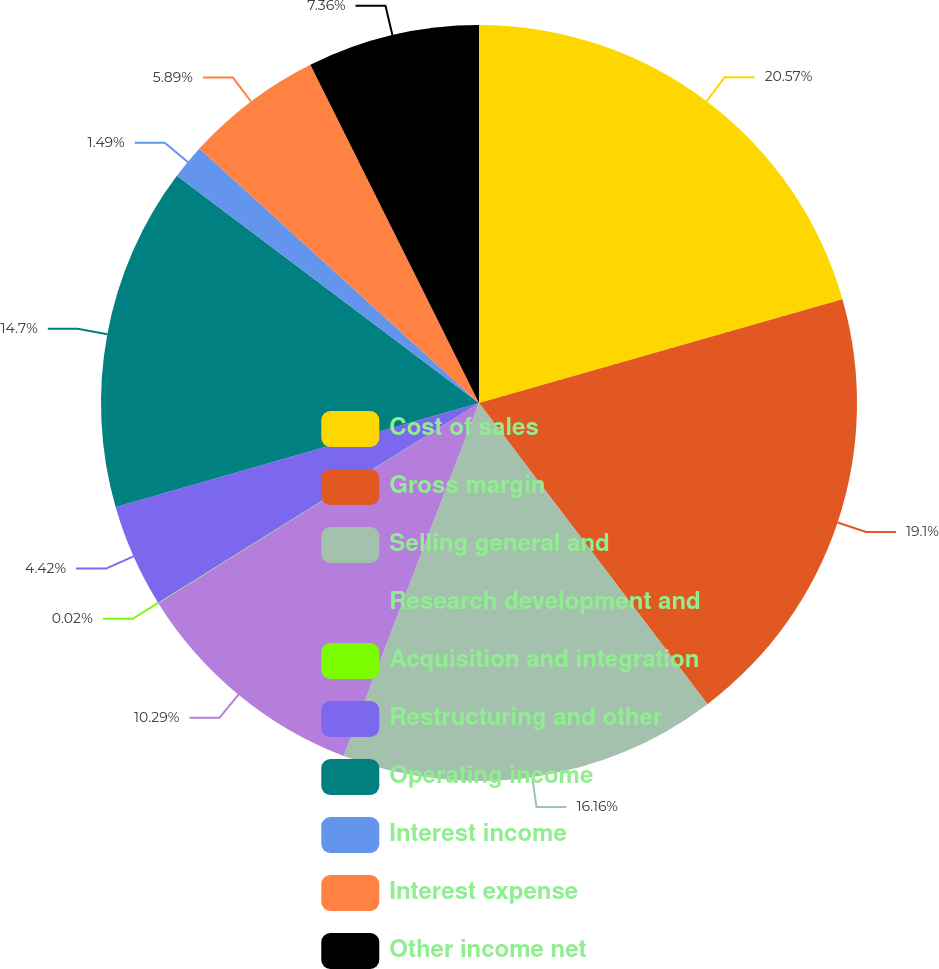Convert chart. <chart><loc_0><loc_0><loc_500><loc_500><pie_chart><fcel>Cost of sales<fcel>Gross margin<fcel>Selling general and<fcel>Research development and<fcel>Acquisition and integration<fcel>Restructuring and other<fcel>Operating income<fcel>Interest income<fcel>Interest expense<fcel>Other income net<nl><fcel>20.57%<fcel>19.1%<fcel>16.16%<fcel>10.29%<fcel>0.02%<fcel>4.42%<fcel>14.7%<fcel>1.49%<fcel>5.89%<fcel>7.36%<nl></chart> 